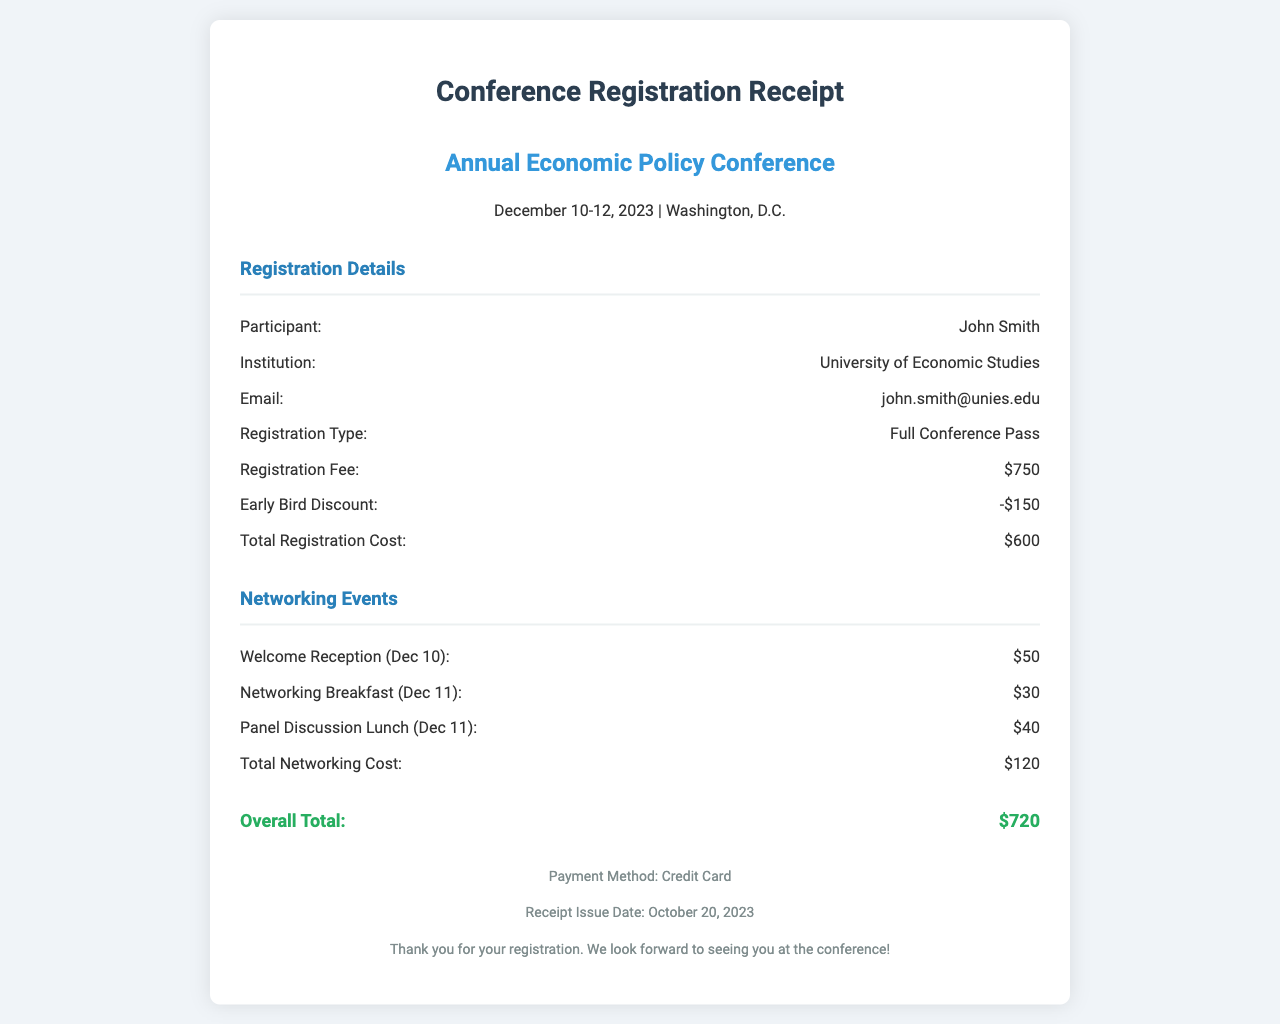What is the name of the participant? The participant's name is listed directly in the registration details of the document.
Answer: John Smith What is the institution of the participant? The document specifies the institution affiliated with the participant in the registration details.
Answer: University of Economic Studies What is the total registration cost? The total registration cost is calculated and displayed in the registration details section.
Answer: $600 How much is the early bird discount? The document explicitly states the amount of the early bird discount under the registration details.
Answer: -$150 What is the total networking cost? The total networking cost sums up the costs of all networking events listed in the document.
Answer: $120 What are the dates of the conference? The conference dates are mentioned in the header section of the document.
Answer: December 10-12, 2023 What is the payment method used for the registration? The payment method for the registration is specified in the footer of the document.
Answer: Credit Card How much does the welcome reception cost? The cost for the welcome reception is listed as part of the networking events in the document.
Answer: $50 What is the receipt issue date? The receipt issue date is noted in the footer of the document.
Answer: October 20, 2023 